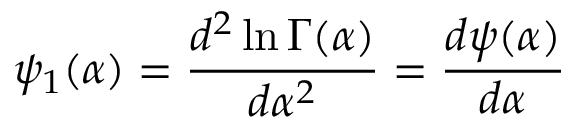Convert formula to latex. <formula><loc_0><loc_0><loc_500><loc_500>\psi _ { 1 } ( \alpha ) = { \frac { d ^ { 2 } \ln \Gamma ( \alpha ) } { d \alpha ^ { 2 } } } = { \frac { d \psi ( \alpha ) } { d \alpha } }</formula> 